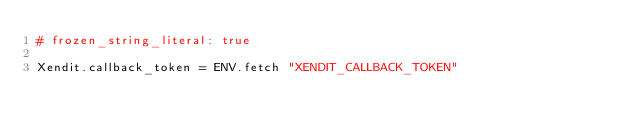<code> <loc_0><loc_0><loc_500><loc_500><_Ruby_># frozen_string_literal: true

Xendit.callback_token = ENV.fetch "XENDIT_CALLBACK_TOKEN"
</code> 